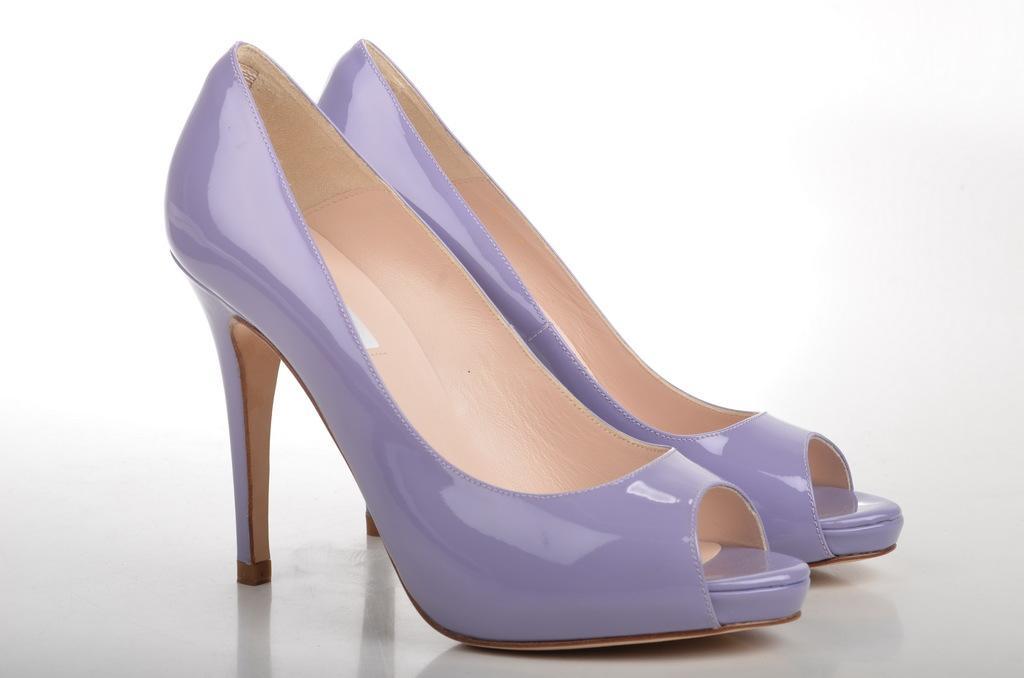Describe this image in one or two sentences. In the picture we can see a pair of high heels which are purple in color placed on the floor. 